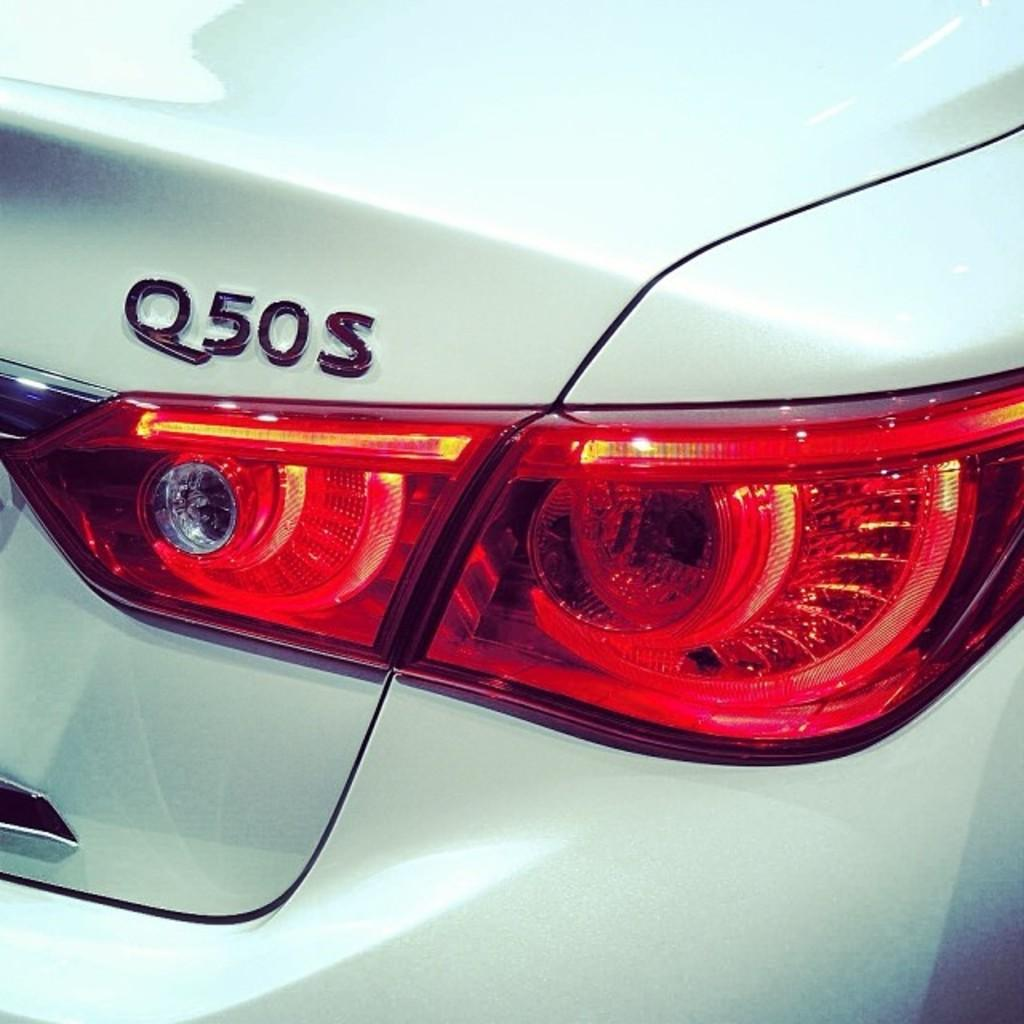What object is visible in the image that has a trunk? There is a trunk visible in the image, which suggests that it belongs to a vehicle. What other feature of the vehicle can be seen in the image? There is a tail light visible in the image. Can you see a face in the image? There is no face present in the image; it features a trunk and a tail light, which are parts of a vehicle. What type of collar is visible in the image? There is no collar present in the image. 